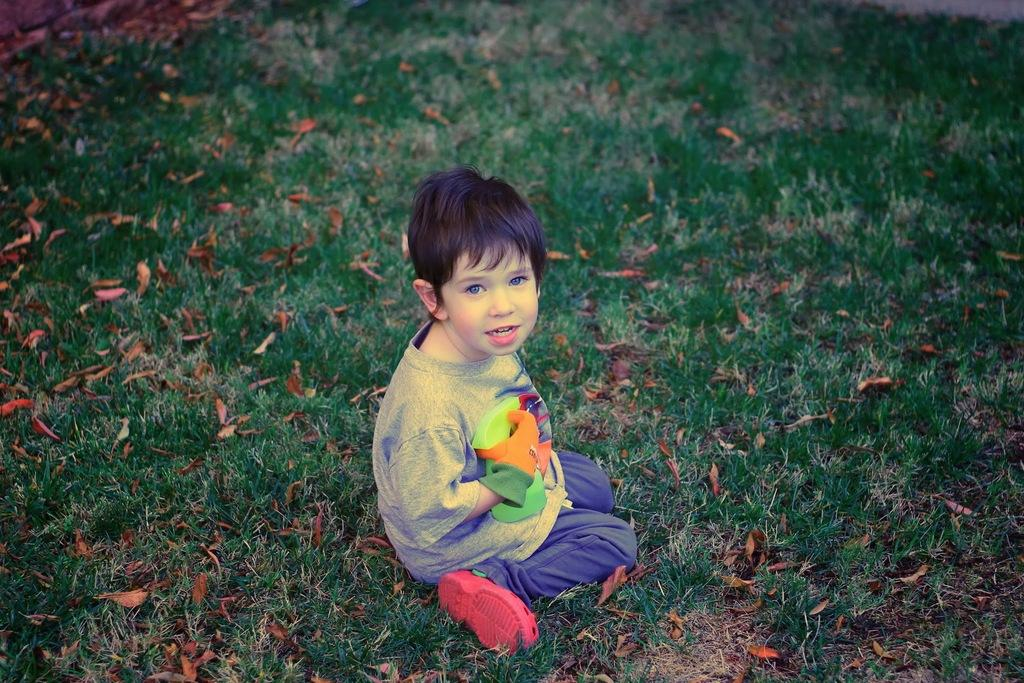What is the boy doing in the image? The boy is sitting on the grass in the image. What is the boy holding in the image? The boy is holding an object in the image. What can be seen on the grass besides the boy? There are dry leaves on the grass in the image. What type of thread is the boy using to fill the hole in the image? There is no thread or hole present in the image; the boy is simply sitting on the grass and holding an object. 